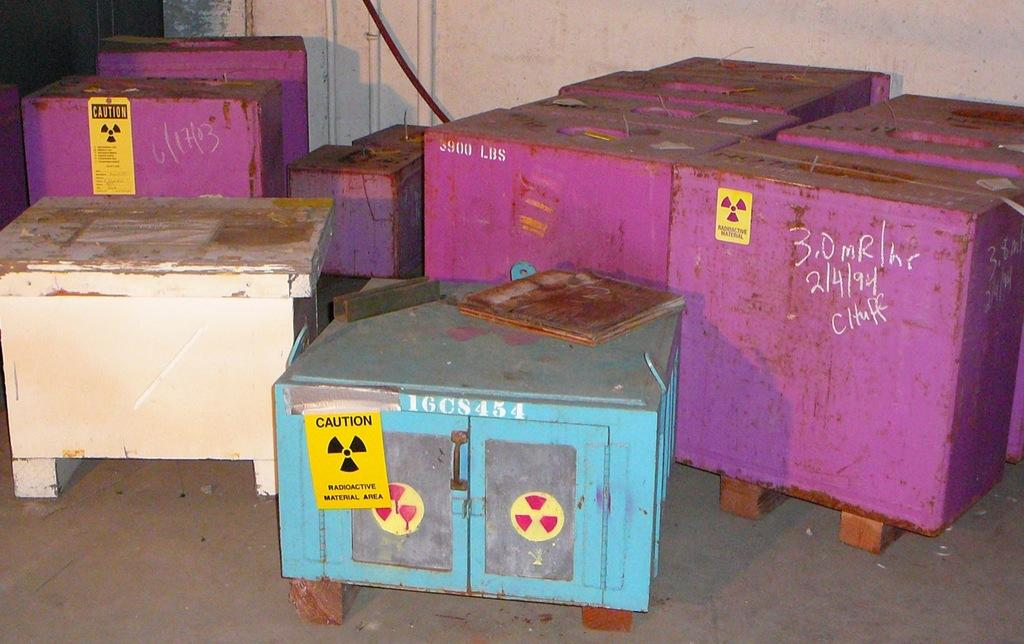<image>
Write a terse but informative summary of the picture. Several crates have caution stickers denoting radioactive material. 